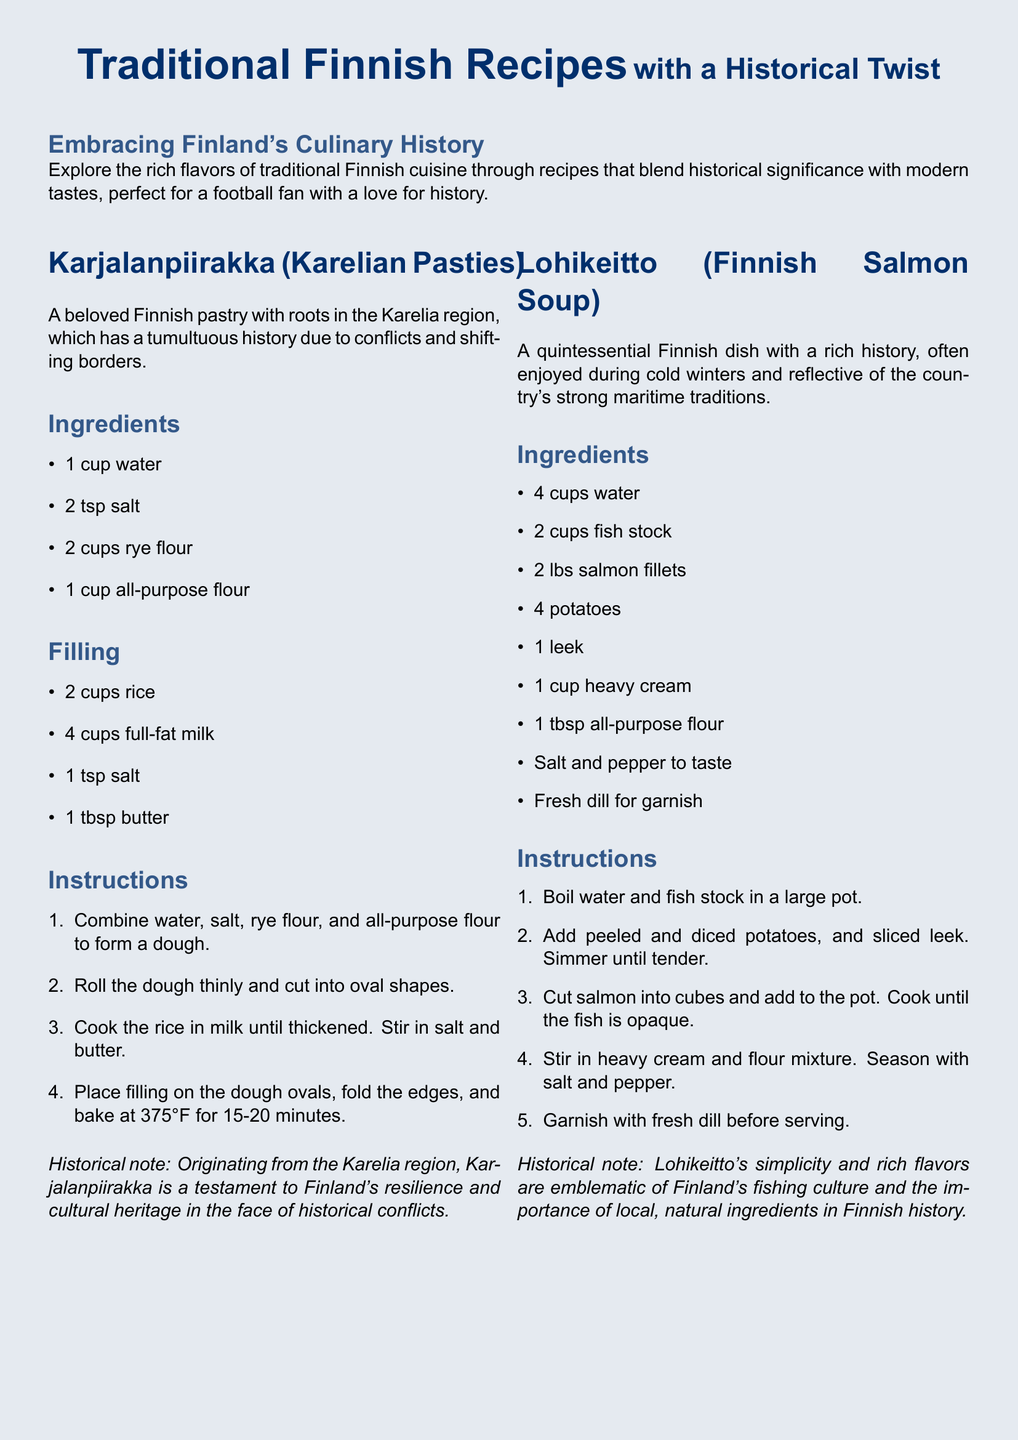What is the main color used in the document's background? The document features a light blue background, indicative of Finnish colors.
Answer: Finnish blue How many main recipes are presented in the document? There are three traditional Finnish recipes showcased in the document.
Answer: Three What is the primary filling ingredient for Karjalanpiirakka? The filling of Karjalanpiirakka primarily consists of rice cooked in milk.
Answer: Rice What historical significance is mentioned regarding Lohikeitto? Lohikeitto reflects Finland's fishing culture and the importance of local ingredients, tying it to historical practices.
Answer: Fishing culture What temperature should the oven be preheated to for Mustikkapiirakka? The document specifies that the oven should be preheated to 375°F for baking Mustikkapiirakka.
Answer: 375°F 